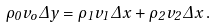<formula> <loc_0><loc_0><loc_500><loc_500>\rho _ { 0 } v _ { o } \Delta y = \rho _ { 1 } v _ { 1 } \Delta x + \rho _ { 2 } v _ { 2 } \Delta x \, .</formula> 